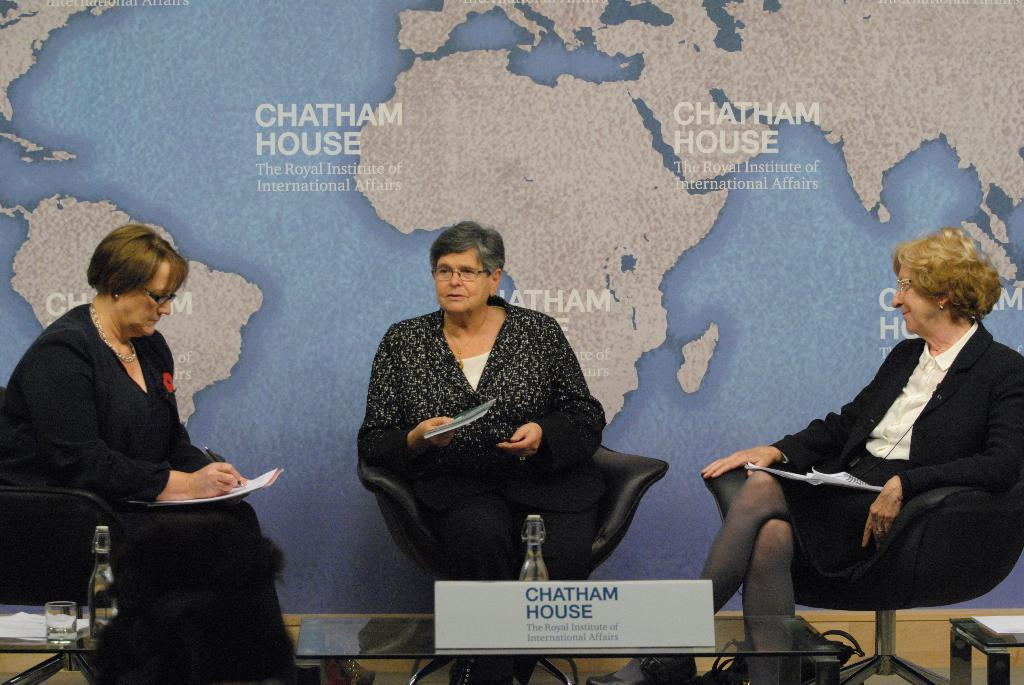How many people are in the image? There are three people in the image. What are the people doing in the image? The people are sitting on chairs and holding books. What objects can be seen on the table in the image? There are bottles, a glass, papers, and a board on the table in the image. What is visible in the background of the image? There is a map in the background of the image. What type of stamp can be seen on the map in the image? There is no stamp visible on the map in the image. 